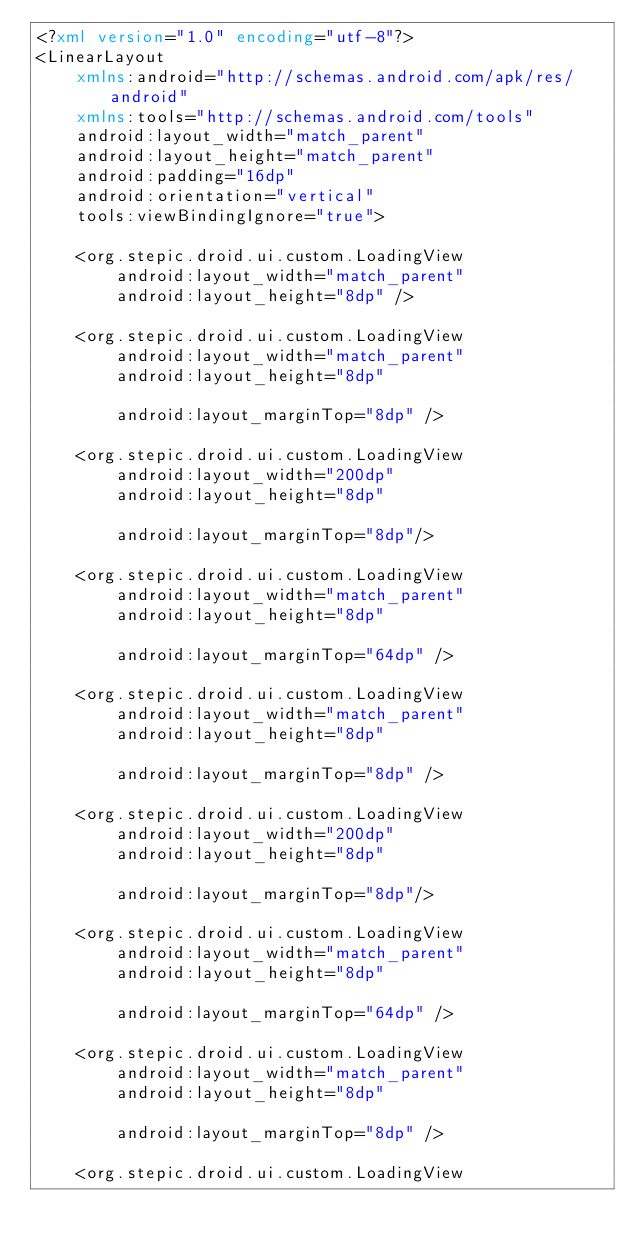<code> <loc_0><loc_0><loc_500><loc_500><_XML_><?xml version="1.0" encoding="utf-8"?>
<LinearLayout
    xmlns:android="http://schemas.android.com/apk/res/android"
    xmlns:tools="http://schemas.android.com/tools"
    android:layout_width="match_parent"
    android:layout_height="match_parent"
    android:padding="16dp"
    android:orientation="vertical"
    tools:viewBindingIgnore="true">

    <org.stepic.droid.ui.custom.LoadingView
        android:layout_width="match_parent"
        android:layout_height="8dp" />

    <org.stepic.droid.ui.custom.LoadingView
        android:layout_width="match_parent"
        android:layout_height="8dp"

        android:layout_marginTop="8dp" />

    <org.stepic.droid.ui.custom.LoadingView
        android:layout_width="200dp"
        android:layout_height="8dp"

        android:layout_marginTop="8dp"/>

    <org.stepic.droid.ui.custom.LoadingView
        android:layout_width="match_parent"
        android:layout_height="8dp"

        android:layout_marginTop="64dp" />

    <org.stepic.droid.ui.custom.LoadingView
        android:layout_width="match_parent"
        android:layout_height="8dp"

        android:layout_marginTop="8dp" />

    <org.stepic.droid.ui.custom.LoadingView
        android:layout_width="200dp"
        android:layout_height="8dp"

        android:layout_marginTop="8dp"/>

    <org.stepic.droid.ui.custom.LoadingView
        android:layout_width="match_parent"
        android:layout_height="8dp"

        android:layout_marginTop="64dp" />

    <org.stepic.droid.ui.custom.LoadingView
        android:layout_width="match_parent"
        android:layout_height="8dp"

        android:layout_marginTop="8dp" />

    <org.stepic.droid.ui.custom.LoadingView</code> 